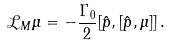Convert formula to latex. <formula><loc_0><loc_0><loc_500><loc_500>\mathcal { L } _ { M } \mu = - \frac { \Gamma _ { 0 } } { 2 } [ \hat { p } , [ \hat { p } , \mu ] ] \, .</formula> 